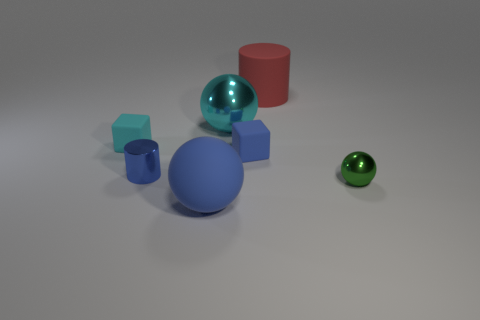Add 2 large blue cylinders. How many objects exist? 9 Subtract all balls. How many objects are left? 4 Add 2 tiny green metallic balls. How many tiny green metallic balls are left? 3 Add 3 tiny green shiny things. How many tiny green shiny things exist? 4 Subtract 0 gray spheres. How many objects are left? 7 Subtract all rubber blocks. Subtract all big metallic spheres. How many objects are left? 4 